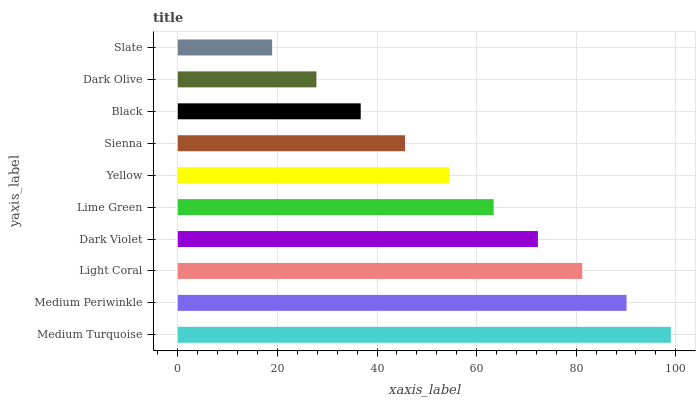Is Slate the minimum?
Answer yes or no. Yes. Is Medium Turquoise the maximum?
Answer yes or no. Yes. Is Medium Periwinkle the minimum?
Answer yes or no. No. Is Medium Periwinkle the maximum?
Answer yes or no. No. Is Medium Turquoise greater than Medium Periwinkle?
Answer yes or no. Yes. Is Medium Periwinkle less than Medium Turquoise?
Answer yes or no. Yes. Is Medium Periwinkle greater than Medium Turquoise?
Answer yes or no. No. Is Medium Turquoise less than Medium Periwinkle?
Answer yes or no. No. Is Lime Green the high median?
Answer yes or no. Yes. Is Yellow the low median?
Answer yes or no. Yes. Is Medium Turquoise the high median?
Answer yes or no. No. Is Light Coral the low median?
Answer yes or no. No. 